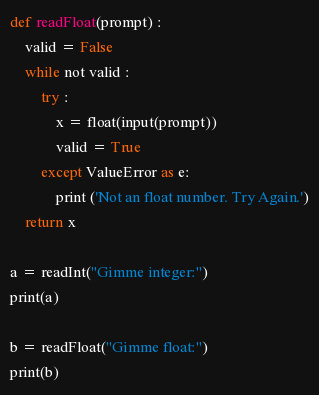<code> <loc_0><loc_0><loc_500><loc_500><_Python_>def readFloat(prompt) :
    valid = False
    while not valid :
        try :
            x = float(input(prompt))
            valid = True
        except ValueError as e:
            print ('Not an float number. Try Again.')
    return x

a = readInt("Gimme integer:")
print(a)

b = readFloat("Gimme float:")
print(b)</code> 